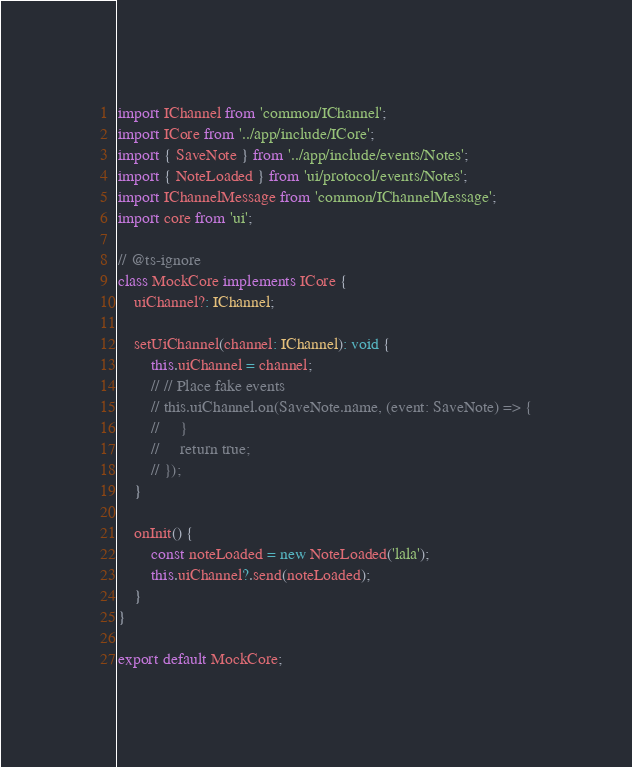<code> <loc_0><loc_0><loc_500><loc_500><_TypeScript_>import IChannel from 'common/IChannel';
import ICore from '../app/include/ICore';
import { SaveNote } from '../app/include/events/Notes';
import { NoteLoaded } from 'ui/protocol/events/Notes';
import IChannelMessage from 'common/IChannelMessage';
import core from 'ui';

// @ts-ignore
class MockCore implements ICore {
    uiChannel?: IChannel;

    setUiChannel(channel: IChannel): void {
        this.uiChannel = channel;
        // // Place fake events
        // this.uiChannel.on(SaveNote.name, (event: SaveNote) => {
        //     }
        //     return true;
        // });
    }

    onInit() {
        const noteLoaded = new NoteLoaded('lala');
        this.uiChannel?.send(noteLoaded);
    }
}

export default MockCore;</code> 